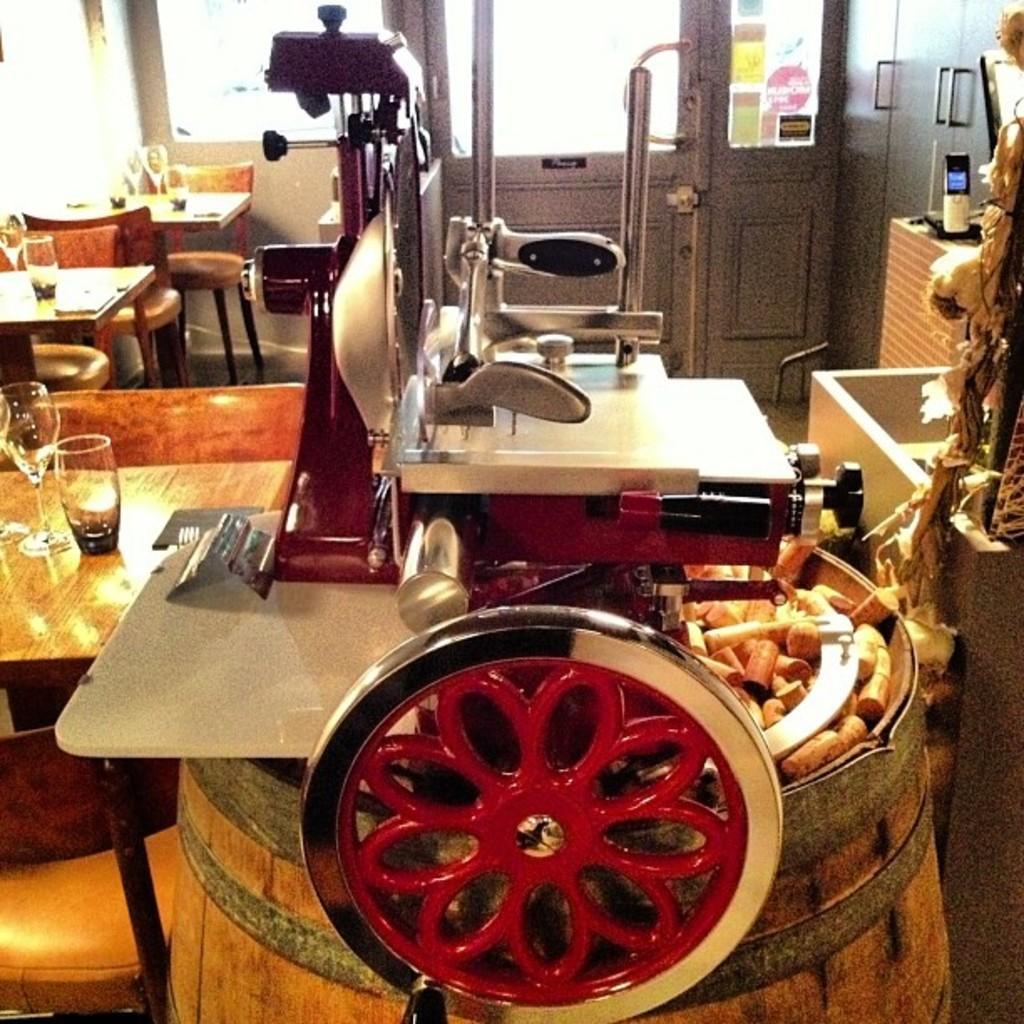In one or two sentences, can you explain what this image depicts? As we can see in the image there is a door, chairs and tables over here and on table there are glasses. 